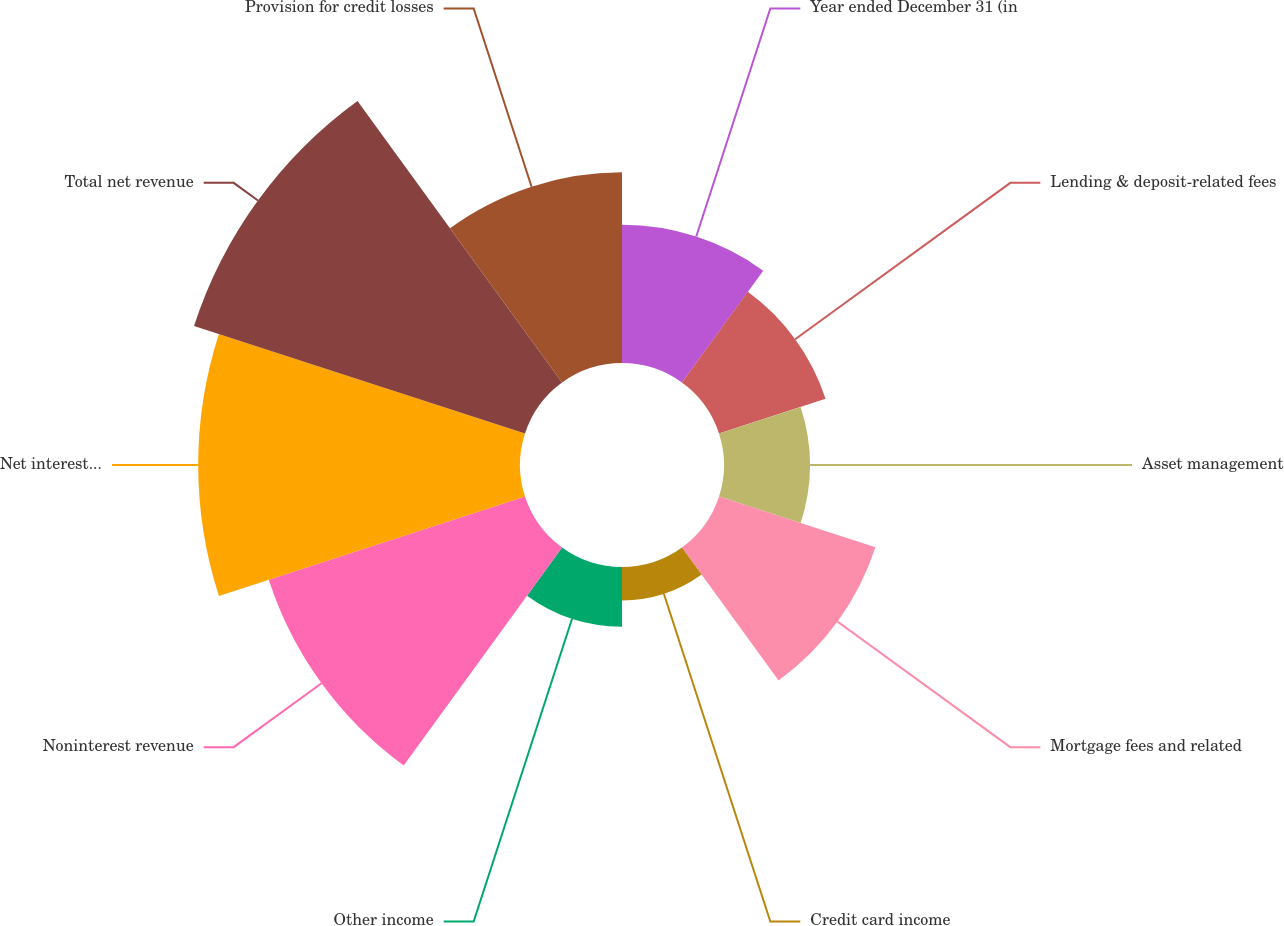<chart> <loc_0><loc_0><loc_500><loc_500><pie_chart><fcel>Year ended December 31 (in<fcel>Lending & deposit-related fees<fcel>Asset management<fcel>Mortgage fees and related<fcel>Credit card income<fcel>Other income<fcel>Noninterest revenue<fcel>Net interest income<fcel>Total net revenue<fcel>Provision for credit losses<nl><fcel>8.02%<fcel>6.5%<fcel>4.98%<fcel>9.54%<fcel>1.94%<fcel>3.46%<fcel>15.63%<fcel>18.67%<fcel>20.19%<fcel>11.06%<nl></chart> 